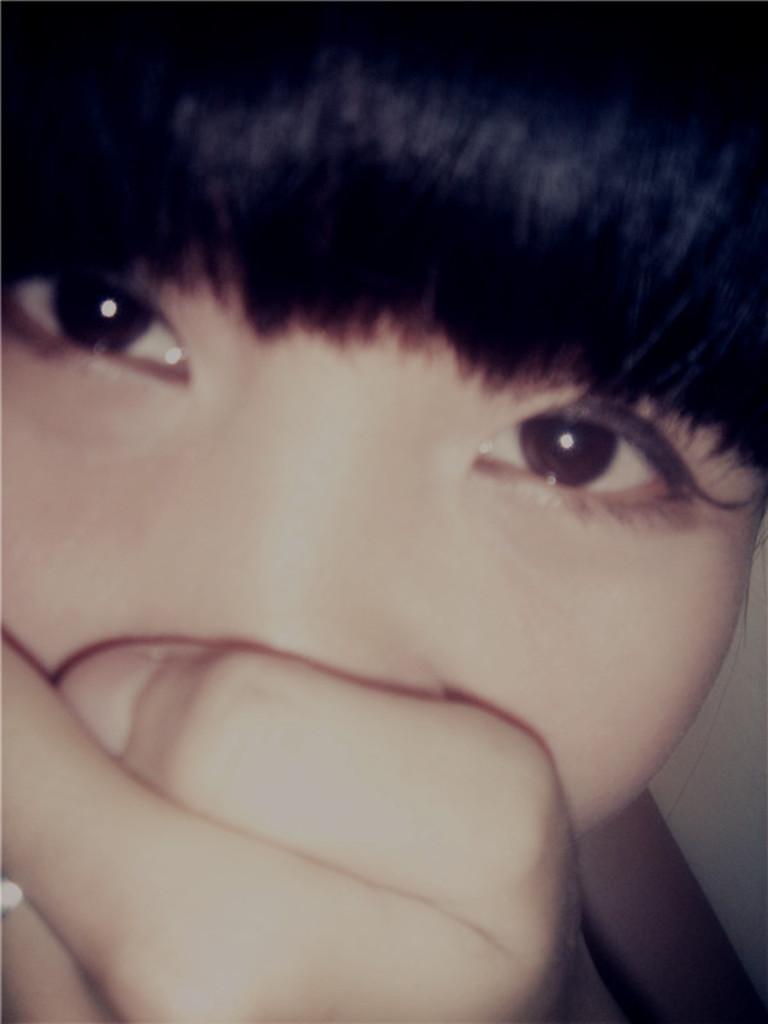Could you give a brief overview of what you see in this image? In this image there is a person putting hand on the face. 